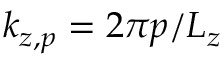Convert formula to latex. <formula><loc_0><loc_0><loc_500><loc_500>k _ { z , p } = 2 \pi p / L _ { z }</formula> 